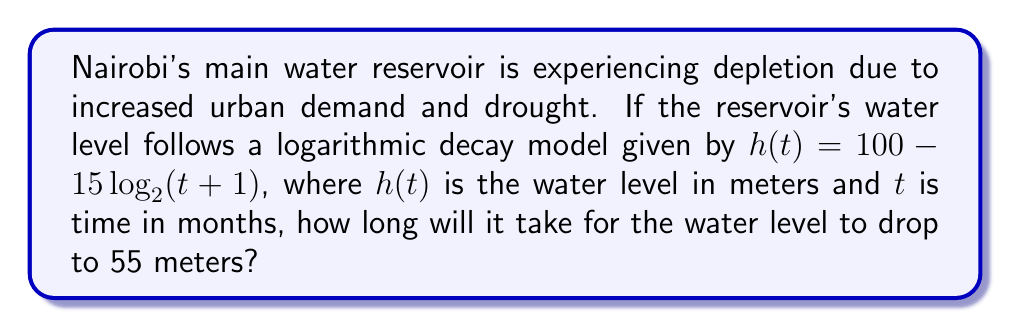Can you answer this question? To solve this problem, we need to follow these steps:

1) We're given the equation: $h(t) = 100 - 15\log_2(t+1)$

2) We want to find $t$ when $h(t) = 55$. So, let's substitute this:

   $55 = 100 - 15\log_2(t+1)$

3) Subtract 100 from both sides:

   $-45 = -15\log_2(t+1)$

4) Divide both sides by -15:

   $3 = \log_2(t+1)$

5) Now, we need to solve for $t$. We can do this by applying $2^x$ to both sides:

   $2^3 = 2^{\log_2(t+1)}$

6) Simplify the left side:

   $8 = t+1$

7) Subtract 1 from both sides:

   $7 = t$

Therefore, it will take 7 months for the water level to drop to 55 meters.
Answer: 7 months 